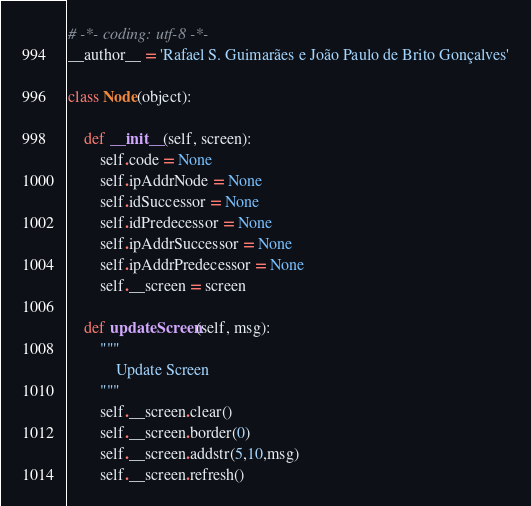<code> <loc_0><loc_0><loc_500><loc_500><_Python_># -*- coding: utf-8 -*-
__author__ = 'Rafael S. Guimarães e João Paulo de Brito Gonçalves'

class Node(object):

    def __init__(self, screen):
        self.code = None
        self.ipAddrNode = None
        self.idSuccessor = None
        self.idPredecessor = None
        self.ipAddrSuccessor = None
        self.ipAddrPredecessor = None
        self.__screen = screen

    def updateScreen(self, msg):
        """
            Update Screen
        """
        self.__screen.clear()
        self.__screen.border(0)
        self.__screen.addstr(5,10,msg)
        self.__screen.refresh()</code> 